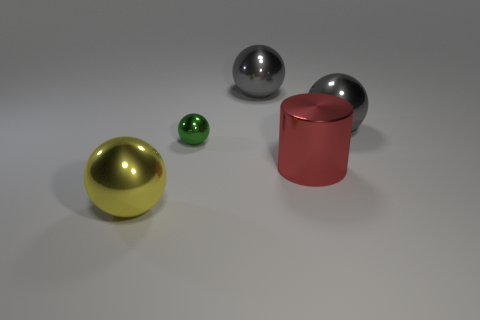Can you describe the colors and materials of the objects in the image? Certainly! There are four objects in the image. Starting from the left, there's a large gold-colored ball with a polished finish, suggestive of a metallic material. Next is a small, vivid green ball with a glassy appearance, reflecting the environment. In the center, you'll find a dull red cylindrical object which resembles painted metal. And finally, to the right is a shiny, medium-sized ball that appears silver and metallic. 